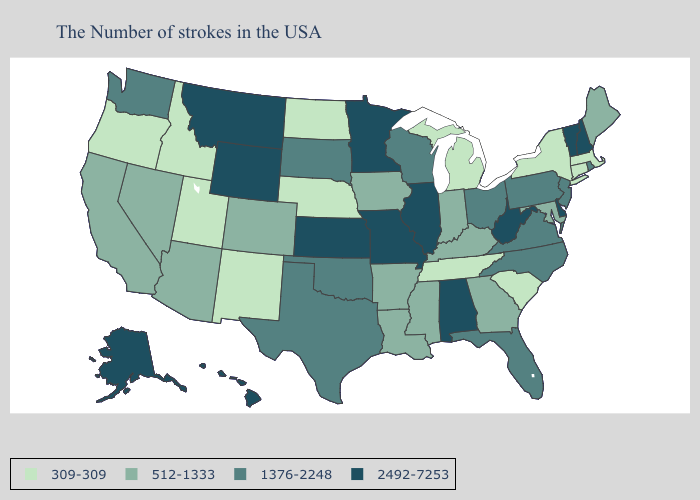What is the value of South Dakota?
Be succinct. 1376-2248. Among the states that border Tennessee , which have the lowest value?
Write a very short answer. Georgia, Kentucky, Mississippi, Arkansas. Among the states that border Tennessee , does Mississippi have the highest value?
Concise answer only. No. Is the legend a continuous bar?
Answer briefly. No. Name the states that have a value in the range 512-1333?
Write a very short answer. Maine, Maryland, Georgia, Kentucky, Indiana, Mississippi, Louisiana, Arkansas, Iowa, Colorado, Arizona, Nevada, California. Does Montana have the lowest value in the West?
Write a very short answer. No. How many symbols are there in the legend?
Keep it brief. 4. What is the value of Vermont?
Write a very short answer. 2492-7253. Which states have the lowest value in the South?
Quick response, please. South Carolina, Tennessee. Name the states that have a value in the range 309-309?
Concise answer only. Massachusetts, Connecticut, New York, South Carolina, Michigan, Tennessee, Nebraska, North Dakota, New Mexico, Utah, Idaho, Oregon. What is the value of South Dakota?
Answer briefly. 1376-2248. What is the value of Vermont?
Quick response, please. 2492-7253. Name the states that have a value in the range 1376-2248?
Keep it brief. Rhode Island, New Jersey, Pennsylvania, Virginia, North Carolina, Ohio, Florida, Wisconsin, Oklahoma, Texas, South Dakota, Washington. What is the highest value in states that border Tennessee?
Quick response, please. 2492-7253. 